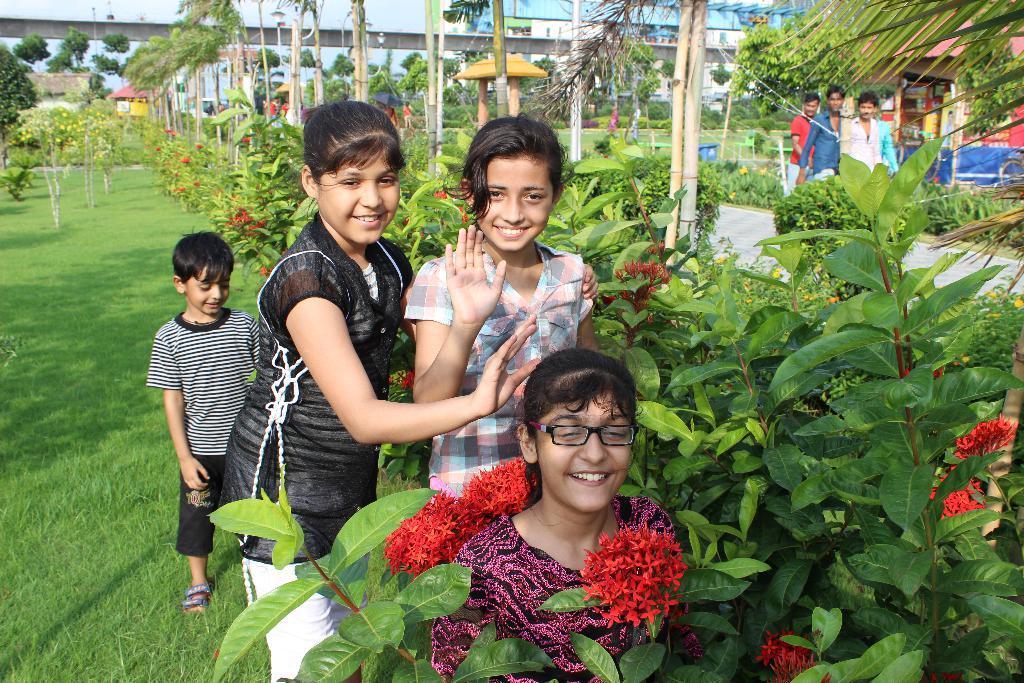In one or two sentences, can you explain what this image depicts? In this picture, we see three girls and a boy are standing. All of them are smiling and they are posing for the photo. On the right side, we see the plants, trees and red color flowers. Behind the trees, we see the wooden sticks and four men are standing. Behind them, we see a tent in red and blue color and we see the posters. Behind that, we see the benches in green and blue color. At the bottom, we see the grass. In the middle, we see the arch like structure. There are trees and the buildings in the background. 